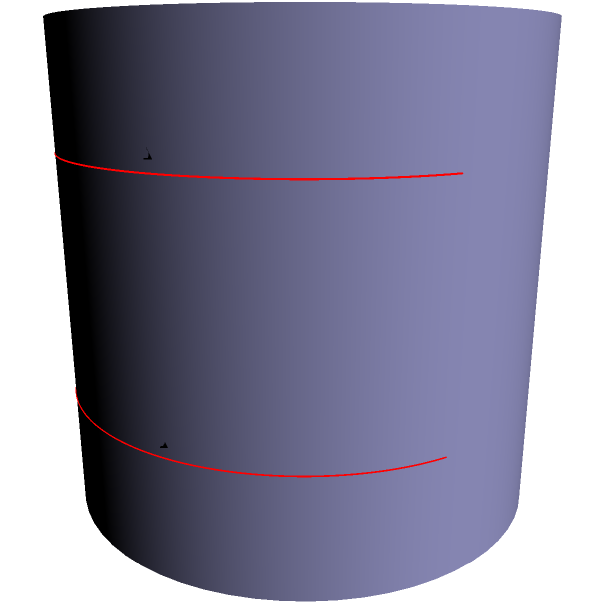In a seismic survey of an oil field, we need to set up parallel survey lines on a cylindrical surface representing a curved geological formation. Two such lines are shown in red on the surface. If the cylindrical surface has a radius of 2 units and the vertical distance between the lines is 1 unit, what is the actual distance between points A and C measured along the surface of the cylinder? To solve this problem, we need to consider the non-Euclidean geometry of the cylindrical surface:

1) On a cylinder, the shortest path between two points is not a straight line, but a helical curve.

2) The surface of a cylinder can be "unrolled" into a flat plane, where the helical path becomes a straight line.

3) In the unrolled plane, we have a right triangle:
   - The base of the triangle is the circumference of the cylinder: $2\pi r = 2\pi(2) = 4\pi$ units
   - The height of the triangle is the vertical distance between the lines: 1 unit

4) We can use the Pythagorean theorem to find the length of the hypotenuse, which represents the actual distance between A and C:

   $d^2 = (4\pi)^2 + 1^2$

5) Solving for d:

   $d = \sqrt{(4\pi)^2 + 1^2} = \sqrt{16\pi^2 + 1}$

6) This can be simplified to:

   $d = \sqrt{16\pi^2 + 1}$ units

This result demonstrates how parallel lines on a curved surface can have a non-intuitive distance relationship, which is crucial for accurate seismic surveying in curved geological formations.
Answer: $\sqrt{16\pi^2 + 1}$ units 